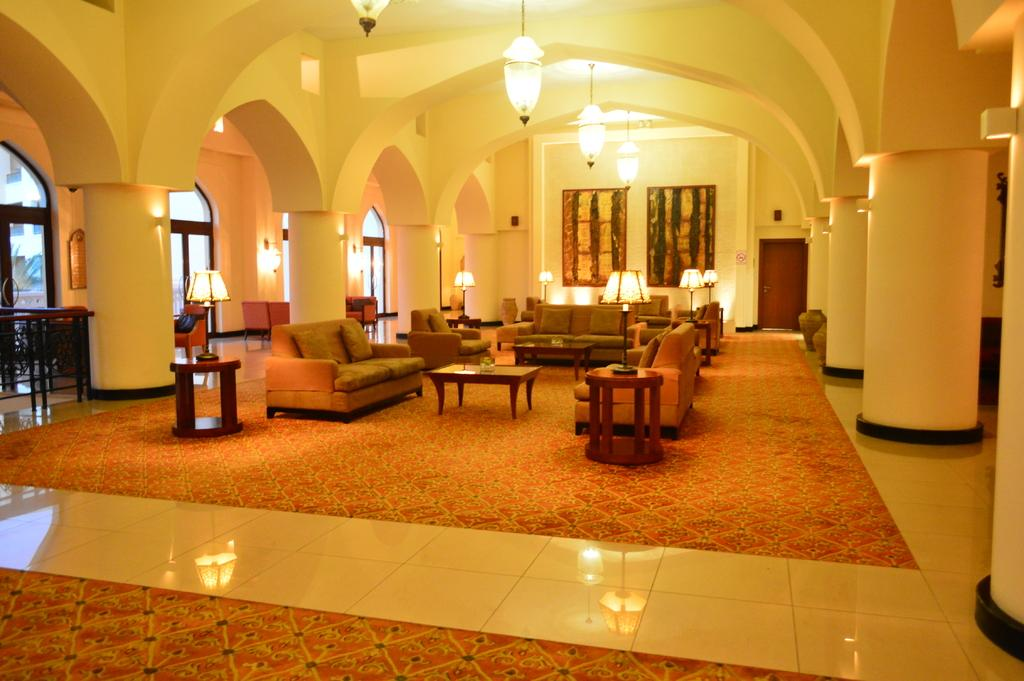What type of furniture is in the image? There are couches in the image. What other piece of furniture can be seen in the image? There is a table in the image. What is placed on the table? A lamp is present on the table. What is visible in the background of the image? There is a window and a wall in the image. What type of lighting fixture is visible at the top of the image? A chandelier is visible at the top of the image. What type of fowl can be seen playing with a toy on the table in the image? There is no fowl or toy present on the table in the image; only a lamp is visible. Can you tell me how many bags of popcorn are on the couches in the image? There is no popcorn visible on the couches in the image. 